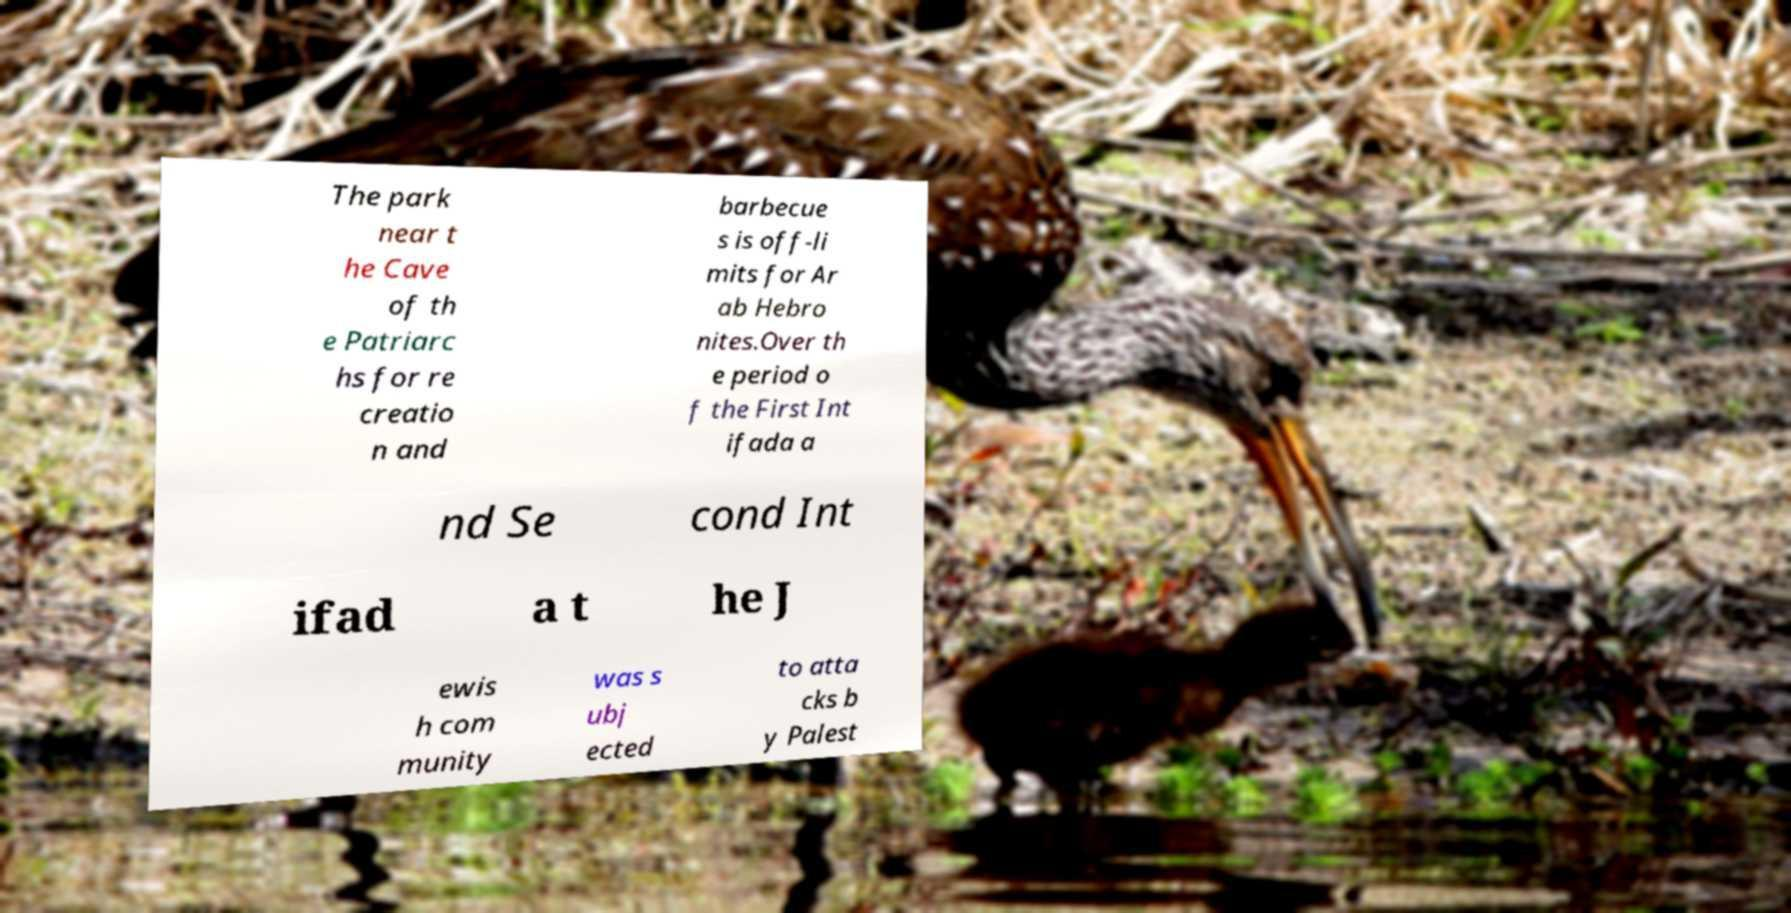I need the written content from this picture converted into text. Can you do that? The park near t he Cave of th e Patriarc hs for re creatio n and barbecue s is off-li mits for Ar ab Hebro nites.Over th e period o f the First Int ifada a nd Se cond Int ifad a t he J ewis h com munity was s ubj ected to atta cks b y Palest 